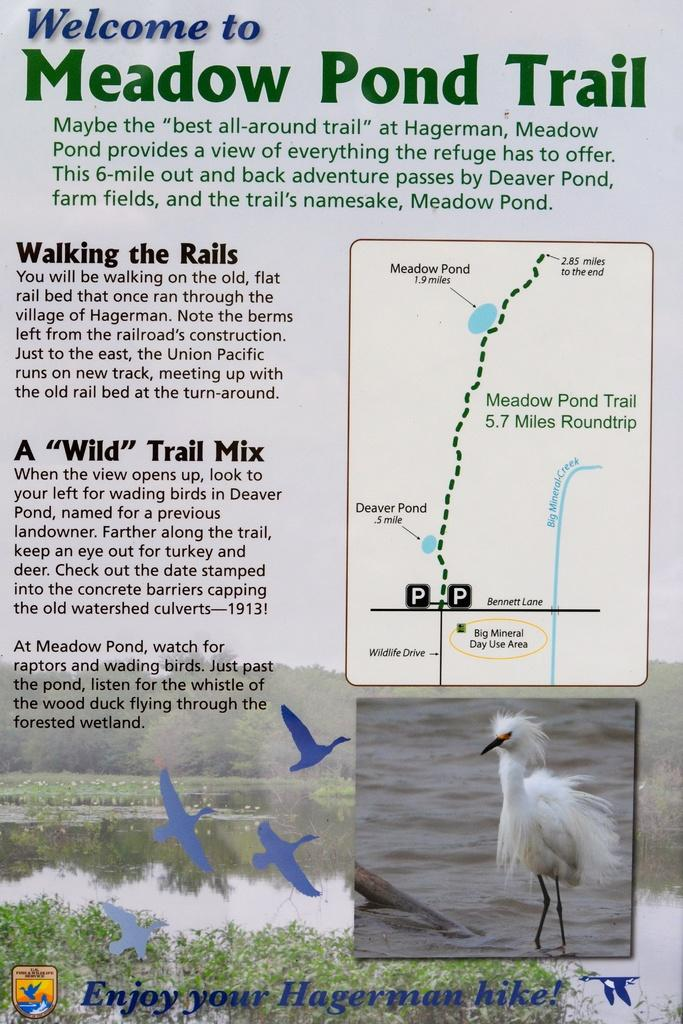What is depicted on the poster in the image? The poster features a bird standing in the water. What additional information is provided on the poster? There is text about the bird on the poster, as well as a route map. What type of operation is being performed on the bird in the image? There is no operation being performed on the bird in the image; it is simply depicted standing in the water on the poster. 